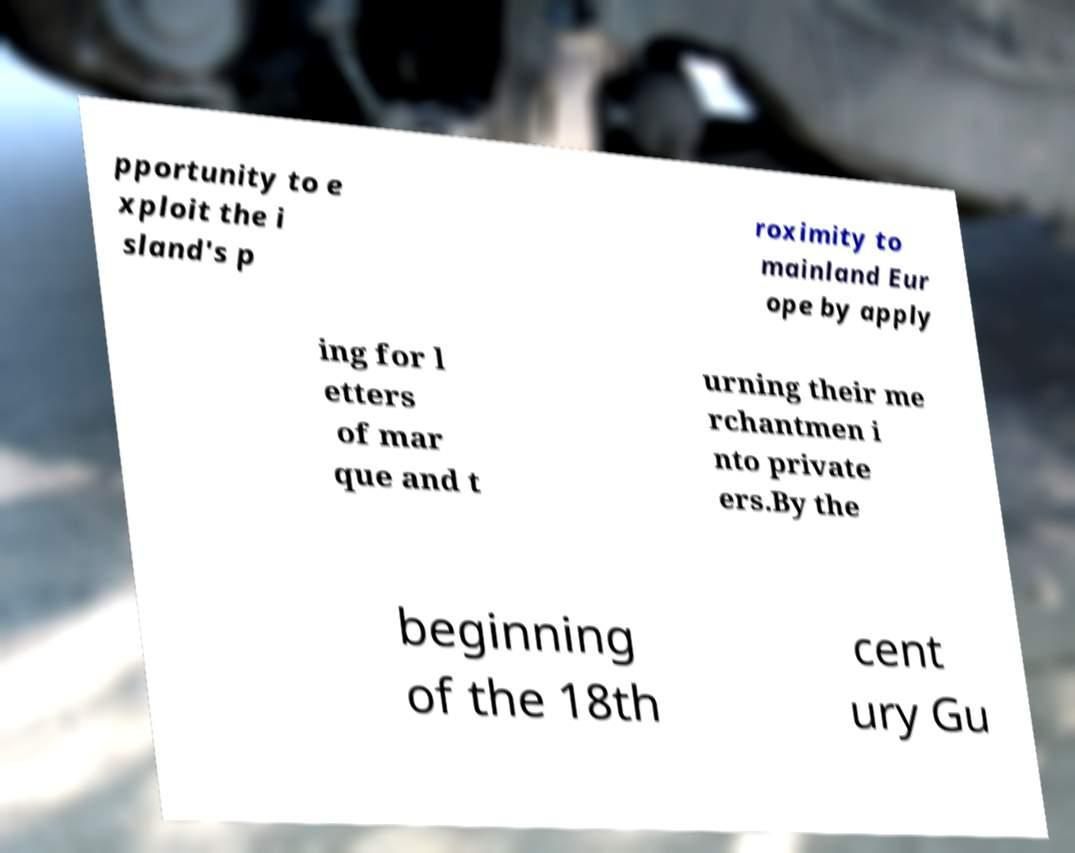For documentation purposes, I need the text within this image transcribed. Could you provide that? pportunity to e xploit the i sland's p roximity to mainland Eur ope by apply ing for l etters of mar que and t urning their me rchantmen i nto private ers.By the beginning of the 18th cent ury Gu 